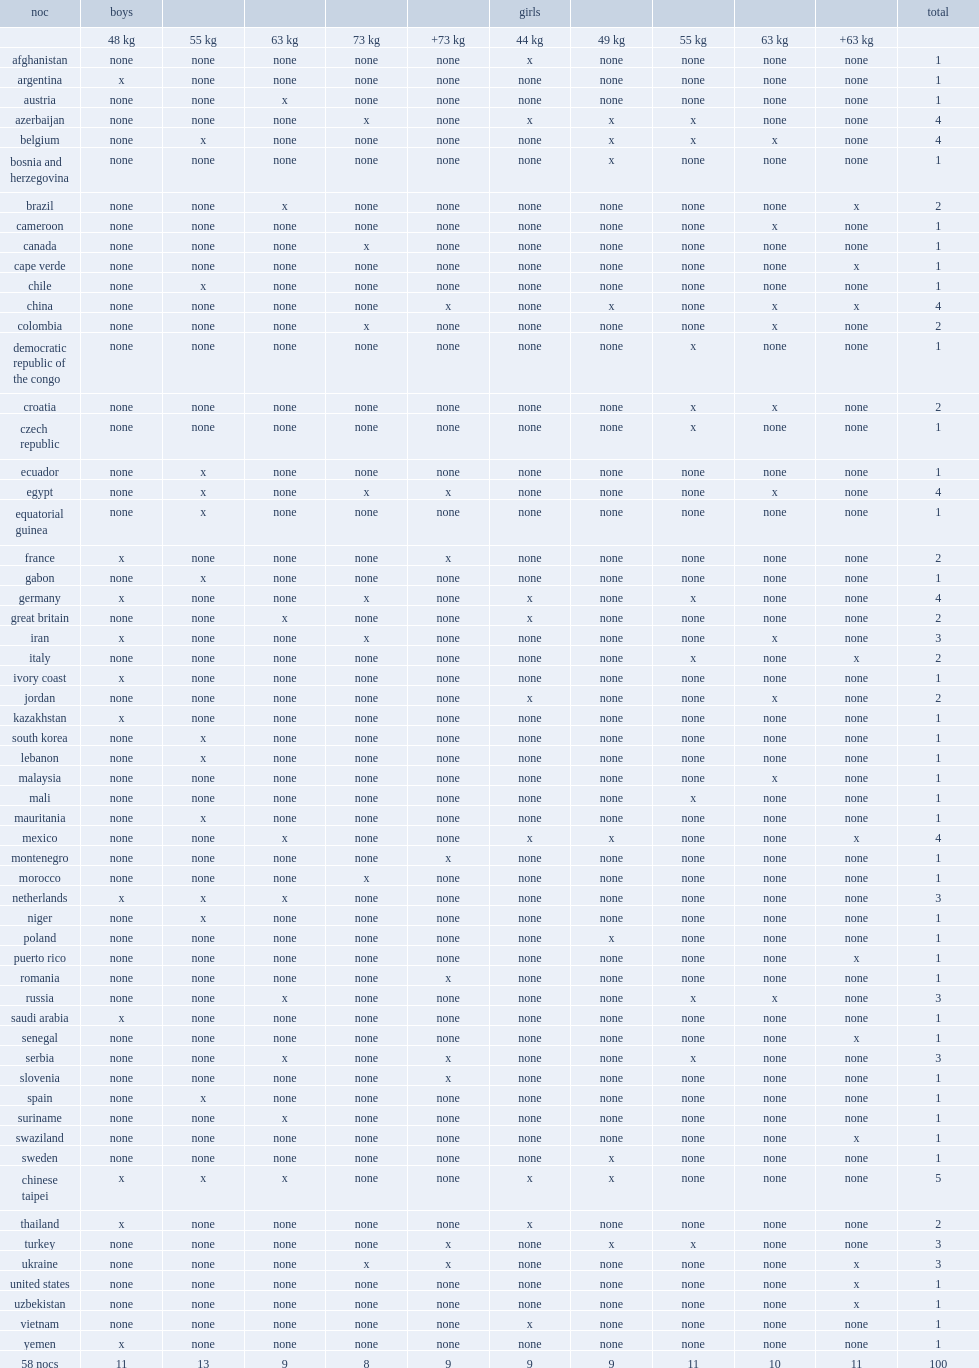Could you parse the entire table as a dict? {'header': ['noc', 'boys', '', '', '', '', 'girls', '', '', '', '', 'total'], 'rows': [['', '48 kg', '55 kg', '63 kg', '73 kg', '+73 kg', '44 kg', '49 kg', '55 kg', '63 kg', '+63 kg', ''], ['afghanistan', 'none', 'none', 'none', 'none', 'none', 'x', 'none', 'none', 'none', 'none', '1'], ['argentina', 'x', 'none', 'none', 'none', 'none', 'none', 'none', 'none', 'none', 'none', '1'], ['austria', 'none', 'none', 'x', 'none', 'none', 'none', 'none', 'none', 'none', 'none', '1'], ['azerbaijan', 'none', 'none', 'none', 'x', 'none', 'x', 'x', 'x', 'none', 'none', '4'], ['belgium', 'none', 'x', 'none', 'none', 'none', 'none', 'x', 'x', 'x', 'none', '4'], ['bosnia and herzegovina', 'none', 'none', 'none', 'none', 'none', 'none', 'x', 'none', 'none', 'none', '1'], ['brazil', 'none', 'none', 'x', 'none', 'none', 'none', 'none', 'none', 'none', 'x', '2'], ['cameroon', 'none', 'none', 'none', 'none', 'none', 'none', 'none', 'none', 'x', 'none', '1'], ['canada', 'none', 'none', 'none', 'x', 'none', 'none', 'none', 'none', 'none', 'none', '1'], ['cape verde', 'none', 'none', 'none', 'none', 'none', 'none', 'none', 'none', 'none', 'x', '1'], ['chile', 'none', 'x', 'none', 'none', 'none', 'none', 'none', 'none', 'none', 'none', '1'], ['china', 'none', 'none', 'none', 'none', 'x', 'none', 'x', 'none', 'x', 'x', '4'], ['colombia', 'none', 'none', 'none', 'x', 'none', 'none', 'none', 'none', 'x', 'none', '2'], ['democratic republic of the congo', 'none', 'none', 'none', 'none', 'none', 'none', 'none', 'x', 'none', 'none', '1'], ['croatia', 'none', 'none', 'none', 'none', 'none', 'none', 'none', 'x', 'x', 'none', '2'], ['czech republic', 'none', 'none', 'none', 'none', 'none', 'none', 'none', 'x', 'none', 'none', '1'], ['ecuador', 'none', 'x', 'none', 'none', 'none', 'none', 'none', 'none', 'none', 'none', '1'], ['egypt', 'none', 'x', 'none', 'x', 'x', 'none', 'none', 'none', 'x', 'none', '4'], ['equatorial guinea', 'none', 'x', 'none', 'none', 'none', 'none', 'none', 'none', 'none', 'none', '1'], ['france', 'x', 'none', 'none', 'none', 'x', 'none', 'none', 'none', 'none', 'none', '2'], ['gabon', 'none', 'x', 'none', 'none', 'none', 'none', 'none', 'none', 'none', 'none', '1'], ['germany', 'x', 'none', 'none', 'x', 'none', 'x', 'none', 'x', 'none', 'none', '4'], ['great britain', 'none', 'none', 'x', 'none', 'none', 'x', 'none', 'none', 'none', 'none', '2'], ['iran', 'x', 'none', 'none', 'x', 'none', 'none', 'none', 'none', 'x', 'none', '3'], ['italy', 'none', 'none', 'none', 'none', 'none', 'none', 'none', 'x', 'none', 'x', '2'], ['ivory coast', 'x', 'none', 'none', 'none', 'none', 'none', 'none', 'none', 'none', 'none', '1'], ['jordan', 'none', 'none', 'none', 'none', 'none', 'x', 'none', 'none', 'x', 'none', '2'], ['kazakhstan', 'x', 'none', 'none', 'none', 'none', 'none', 'none', 'none', 'none', 'none', '1'], ['south korea', 'none', 'x', 'none', 'none', 'none', 'none', 'none', 'none', 'none', 'none', '1'], ['lebanon', 'none', 'x', 'none', 'none', 'none', 'none', 'none', 'none', 'none', 'none', '1'], ['malaysia', 'none', 'none', 'none', 'none', 'none', 'none', 'none', 'none', 'x', 'none', '1'], ['mali', 'none', 'none', 'none', 'none', 'none', 'none', 'none', 'x', 'none', 'none', '1'], ['mauritania', 'none', 'x', 'none', 'none', 'none', 'none', 'none', 'none', 'none', 'none', '1'], ['mexico', 'none', 'none', 'x', 'none', 'none', 'x', 'x', 'none', 'none', 'x', '4'], ['montenegro', 'none', 'none', 'none', 'none', 'x', 'none', 'none', 'none', 'none', 'none', '1'], ['morocco', 'none', 'none', 'none', 'x', 'none', 'none', 'none', 'none', 'none', 'none', '1'], ['netherlands', 'x', 'x', 'x', 'none', 'none', 'none', 'none', 'none', 'none', 'none', '3'], ['niger', 'none', 'x', 'none', 'none', 'none', 'none', 'none', 'none', 'none', 'none', '1'], ['poland', 'none', 'none', 'none', 'none', 'none', 'none', 'x', 'none', 'none', 'none', '1'], ['puerto rico', 'none', 'none', 'none', 'none', 'none', 'none', 'none', 'none', 'none', 'x', '1'], ['romania', 'none', 'none', 'none', 'none', 'x', 'none', 'none', 'none', 'none', 'none', '1'], ['russia', 'none', 'none', 'x', 'none', 'none', 'none', 'none', 'x', 'x', 'none', '3'], ['saudi arabia', 'x', 'none', 'none', 'none', 'none', 'none', 'none', 'none', 'none', 'none', '1'], ['senegal', 'none', 'none', 'none', 'none', 'none', 'none', 'none', 'none', 'none', 'x', '1'], ['serbia', 'none', 'none', 'x', 'none', 'x', 'none', 'none', 'x', 'none', 'none', '3'], ['slovenia', 'none', 'none', 'none', 'none', 'x', 'none', 'none', 'none', 'none', 'none', '1'], ['spain', 'none', 'x', 'none', 'none', 'none', 'none', 'none', 'none', 'none', 'none', '1'], ['suriname', 'none', 'none', 'x', 'none', 'none', 'none', 'none', 'none', 'none', 'none', '1'], ['swaziland', 'none', 'none', 'none', 'none', 'none', 'none', 'none', 'none', 'none', 'x', '1'], ['sweden', 'none', 'none', 'none', 'none', 'none', 'none', 'x', 'none', 'none', 'none', '1'], ['chinese taipei', 'x', 'x', 'x', 'none', 'none', 'x', 'x', 'none', 'none', 'none', '5'], ['thailand', 'x', 'none', 'none', 'none', 'none', 'x', 'none', 'none', 'none', 'none', '2'], ['turkey', 'none', 'none', 'none', 'none', 'x', 'none', 'x', 'x', 'none', 'none', '3'], ['ukraine', 'none', 'none', 'none', 'x', 'x', 'none', 'none', 'none', 'none', 'x', '3'], ['united states', 'none', 'none', 'none', 'none', 'none', 'none', 'none', 'none', 'none', 'x', '1'], ['uzbekistan', 'none', 'none', 'none', 'none', 'none', 'none', 'none', 'none', 'none', 'x', '1'], ['vietnam', 'none', 'none', 'none', 'none', 'none', 'x', 'none', 'none', 'none', 'none', '1'], ['yemen', 'x', 'none', 'none', 'none', 'none', 'none', 'none', 'none', 'none', 'none', '1'], ['58 nocs', '11', '13', '9', '8', '9', '9', '9', '11', '10', '11', '100']]} Which weight category did boys in china participate in? +73 kg. 